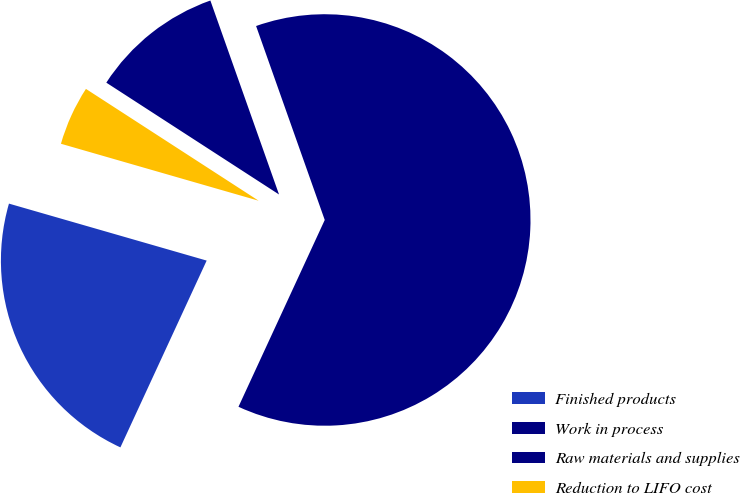Convert chart. <chart><loc_0><loc_0><loc_500><loc_500><pie_chart><fcel>Finished products<fcel>Work in process<fcel>Raw materials and supplies<fcel>Reduction to LIFO cost<nl><fcel>22.58%<fcel>62.3%<fcel>10.44%<fcel>4.68%<nl></chart> 